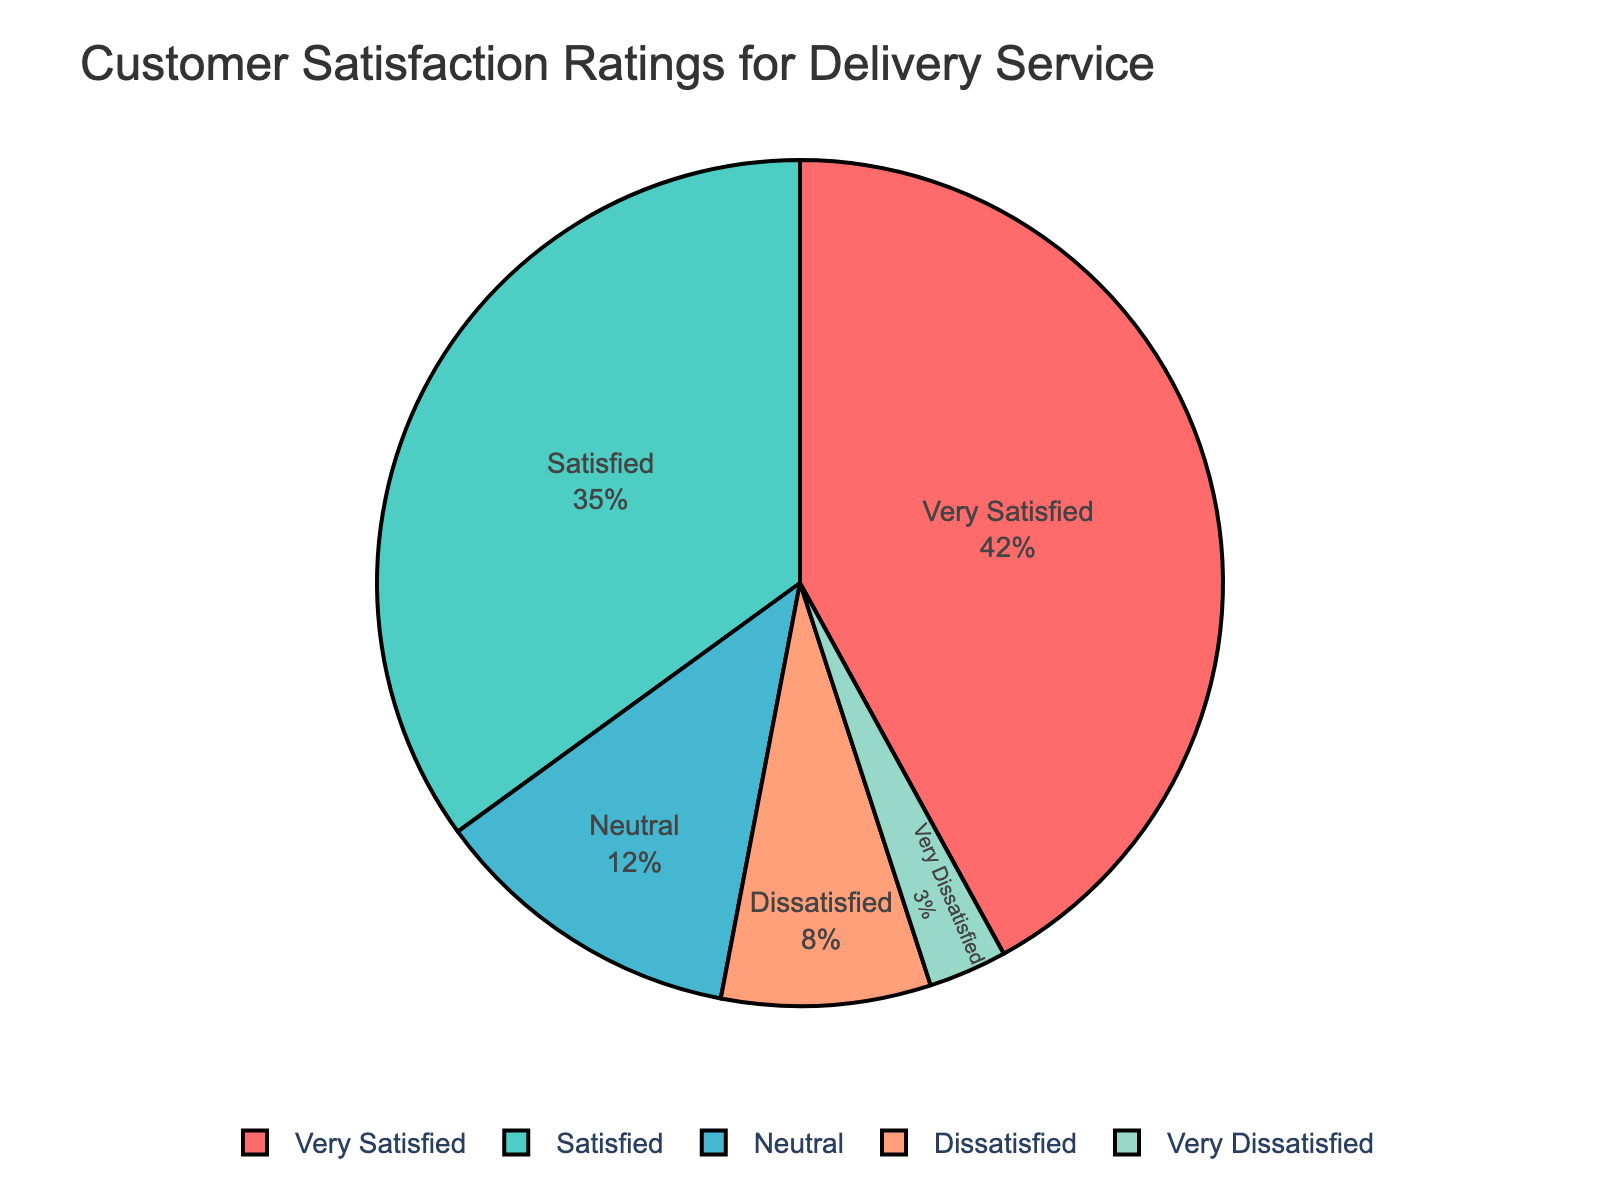What is the percentage of customers who are either Very Satisfied or Satisfied? Adding the percentages of Very Satisfied and Satisfied ratings: 42% (Very Satisfied) + 35% (Satisfied) = 77%
Answer: 77% Which rating has the lowest percentage? The rating with the lowest percentage is the one represented by the smallest segment in the pie chart. The Very Dissatisfied rating has a percentage of 3%, which is the lowest.
Answer: Very Dissatisfied What is the difference in percentage between the Satisfied and Dissatisfied ratings? Subtract the percentage of Dissatisfied from Satisfied ratings: 35% (Satisfied) - 8% (Dissatisfied) = 27%
Answer: 27% How many times greater is the percentage of Very Satisfied customers compared to Very Dissatisfied customers? Divide the percentage of Very Satisfied by the percentage of Very Dissatisfied: 42% / 3% = 14 times
Answer: 14 times What portion of the pie chart is made up of dissatisfied customers (Dissatisfied and Very Dissatisfied combined)? Adding the percentages of Dissatisfied and Very Dissatisfied ratings: 8% (Dissatisfied) + 3% (Very Dissatisfied) = 11%
Answer: 11% How does the percentage of Neutral customers compare to Satisfied customers? The percentage of Neutral customers is 12%, while the percentage of Satisfied customers is 35%. The Neutral customer percentage is 23% less than the Satisfied customer percentage.
Answer: 23% less If you combine satisfied and dissatisfied ratings, what percentage of customers would that include? Adding the percentages of Very Satisfied, Satisfied, Dissatisfied, and Very Dissatisfied ratings: 42% (Very Satisfied) + 35% (Satisfied) + 8% (Dissatisfied) + 3% (Very Dissatisfied) = 88%
Answer: 88% What is the most dominant color in the pie chart and what rating does it represent? The largest segment in the pie chart is typically the most dominant color. The segment for the Very Satisfied rating, which represents 42%, is the most dominant and is colored red.
Answer: Red, Very Satisfied Calculate the ratio of Satisfied to Neutral ratings. Divide the percentage of Satisfied by the percentage of Neutral: 35% / 12% ≈ 2.92
Answer: ≈ 2.92 